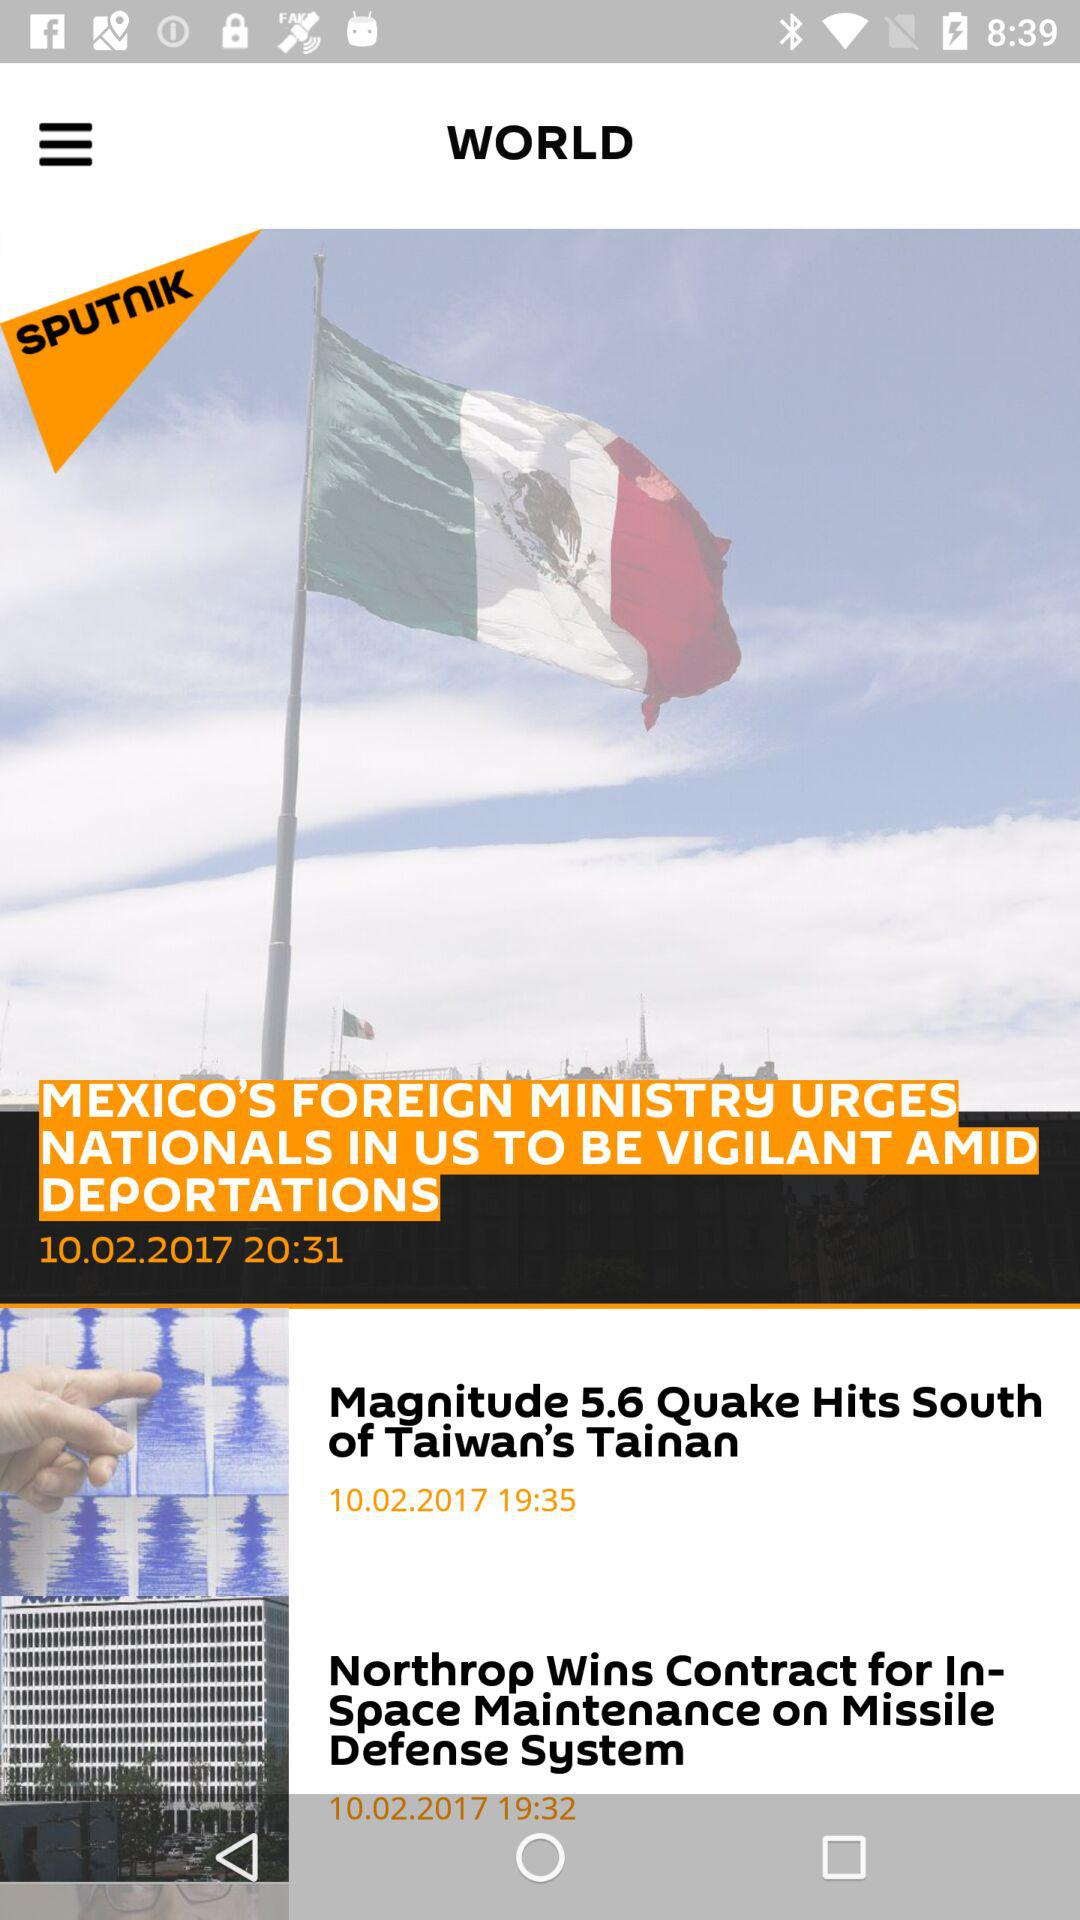What is the publication time of the article "Mexico's Foreign Ministry Urges Nationals in Us to be Vigilant Amid Deportations"? The publication time is 20:31. 